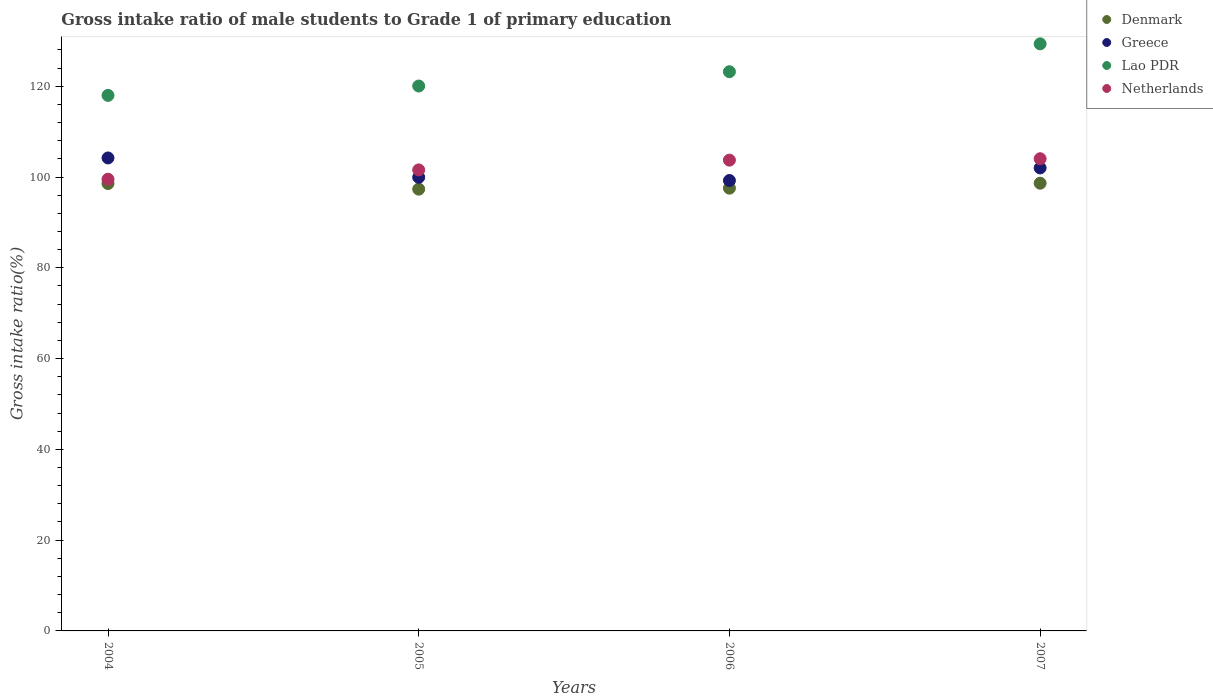Is the number of dotlines equal to the number of legend labels?
Your answer should be compact. Yes. What is the gross intake ratio in Lao PDR in 2004?
Give a very brief answer. 118. Across all years, what is the maximum gross intake ratio in Denmark?
Keep it short and to the point. 98.65. Across all years, what is the minimum gross intake ratio in Denmark?
Give a very brief answer. 97.34. What is the total gross intake ratio in Lao PDR in the graph?
Provide a short and direct response. 490.62. What is the difference between the gross intake ratio in Greece in 2004 and that in 2005?
Give a very brief answer. 4.26. What is the difference between the gross intake ratio in Denmark in 2006 and the gross intake ratio in Greece in 2007?
Ensure brevity in your answer.  -4.46. What is the average gross intake ratio in Greece per year?
Provide a succinct answer. 101.35. In the year 2005, what is the difference between the gross intake ratio in Lao PDR and gross intake ratio in Greece?
Make the answer very short. 20.11. What is the ratio of the gross intake ratio in Denmark in 2004 to that in 2007?
Provide a short and direct response. 1. Is the gross intake ratio in Denmark in 2005 less than that in 2006?
Keep it short and to the point. Yes. What is the difference between the highest and the second highest gross intake ratio in Netherlands?
Offer a very short reply. 0.31. What is the difference between the highest and the lowest gross intake ratio in Denmark?
Ensure brevity in your answer.  1.31. In how many years, is the gross intake ratio in Greece greater than the average gross intake ratio in Greece taken over all years?
Keep it short and to the point. 2. Is it the case that in every year, the sum of the gross intake ratio in Greece and gross intake ratio in Netherlands  is greater than the sum of gross intake ratio in Lao PDR and gross intake ratio in Denmark?
Provide a succinct answer. Yes. Is the gross intake ratio in Lao PDR strictly greater than the gross intake ratio in Denmark over the years?
Keep it short and to the point. Yes. How many years are there in the graph?
Offer a terse response. 4. What is the difference between two consecutive major ticks on the Y-axis?
Ensure brevity in your answer.  20. Does the graph contain any zero values?
Make the answer very short. No. Does the graph contain grids?
Your response must be concise. No. How many legend labels are there?
Your response must be concise. 4. How are the legend labels stacked?
Your answer should be very brief. Vertical. What is the title of the graph?
Provide a short and direct response. Gross intake ratio of male students to Grade 1 of primary education. Does "El Salvador" appear as one of the legend labels in the graph?
Ensure brevity in your answer.  No. What is the label or title of the X-axis?
Your answer should be very brief. Years. What is the label or title of the Y-axis?
Your answer should be very brief. Gross intake ratio(%). What is the Gross intake ratio(%) of Denmark in 2004?
Ensure brevity in your answer.  98.58. What is the Gross intake ratio(%) in Greece in 2004?
Offer a terse response. 104.21. What is the Gross intake ratio(%) of Lao PDR in 2004?
Offer a terse response. 118. What is the Gross intake ratio(%) of Netherlands in 2004?
Ensure brevity in your answer.  99.53. What is the Gross intake ratio(%) in Denmark in 2005?
Make the answer very short. 97.34. What is the Gross intake ratio(%) in Greece in 2005?
Your answer should be compact. 99.95. What is the Gross intake ratio(%) of Lao PDR in 2005?
Your response must be concise. 120.06. What is the Gross intake ratio(%) of Netherlands in 2005?
Offer a very short reply. 101.58. What is the Gross intake ratio(%) in Denmark in 2006?
Make the answer very short. 97.55. What is the Gross intake ratio(%) in Greece in 2006?
Give a very brief answer. 99.24. What is the Gross intake ratio(%) in Lao PDR in 2006?
Your answer should be very brief. 123.21. What is the Gross intake ratio(%) of Netherlands in 2006?
Make the answer very short. 103.73. What is the Gross intake ratio(%) in Denmark in 2007?
Ensure brevity in your answer.  98.65. What is the Gross intake ratio(%) in Greece in 2007?
Make the answer very short. 102.01. What is the Gross intake ratio(%) of Lao PDR in 2007?
Ensure brevity in your answer.  129.36. What is the Gross intake ratio(%) of Netherlands in 2007?
Your answer should be very brief. 104.04. Across all years, what is the maximum Gross intake ratio(%) of Denmark?
Provide a succinct answer. 98.65. Across all years, what is the maximum Gross intake ratio(%) in Greece?
Your answer should be compact. 104.21. Across all years, what is the maximum Gross intake ratio(%) of Lao PDR?
Provide a succinct answer. 129.36. Across all years, what is the maximum Gross intake ratio(%) of Netherlands?
Make the answer very short. 104.04. Across all years, what is the minimum Gross intake ratio(%) of Denmark?
Ensure brevity in your answer.  97.34. Across all years, what is the minimum Gross intake ratio(%) of Greece?
Your answer should be compact. 99.24. Across all years, what is the minimum Gross intake ratio(%) in Lao PDR?
Ensure brevity in your answer.  118. Across all years, what is the minimum Gross intake ratio(%) of Netherlands?
Give a very brief answer. 99.53. What is the total Gross intake ratio(%) in Denmark in the graph?
Offer a very short reply. 392.12. What is the total Gross intake ratio(%) in Greece in the graph?
Your response must be concise. 405.42. What is the total Gross intake ratio(%) in Lao PDR in the graph?
Your answer should be very brief. 490.62. What is the total Gross intake ratio(%) in Netherlands in the graph?
Your response must be concise. 408.88. What is the difference between the Gross intake ratio(%) of Denmark in 2004 and that in 2005?
Your answer should be very brief. 1.24. What is the difference between the Gross intake ratio(%) in Greece in 2004 and that in 2005?
Keep it short and to the point. 4.26. What is the difference between the Gross intake ratio(%) in Lao PDR in 2004 and that in 2005?
Your answer should be compact. -2.07. What is the difference between the Gross intake ratio(%) of Netherlands in 2004 and that in 2005?
Provide a succinct answer. -2.05. What is the difference between the Gross intake ratio(%) of Denmark in 2004 and that in 2006?
Offer a terse response. 1.03. What is the difference between the Gross intake ratio(%) in Greece in 2004 and that in 2006?
Offer a very short reply. 4.97. What is the difference between the Gross intake ratio(%) in Lao PDR in 2004 and that in 2006?
Make the answer very short. -5.22. What is the difference between the Gross intake ratio(%) in Netherlands in 2004 and that in 2006?
Your response must be concise. -4.2. What is the difference between the Gross intake ratio(%) of Denmark in 2004 and that in 2007?
Offer a very short reply. -0.07. What is the difference between the Gross intake ratio(%) of Greece in 2004 and that in 2007?
Your response must be concise. 2.2. What is the difference between the Gross intake ratio(%) of Lao PDR in 2004 and that in 2007?
Provide a short and direct response. -11.36. What is the difference between the Gross intake ratio(%) of Netherlands in 2004 and that in 2007?
Provide a succinct answer. -4.51. What is the difference between the Gross intake ratio(%) of Denmark in 2005 and that in 2006?
Keep it short and to the point. -0.21. What is the difference between the Gross intake ratio(%) of Greece in 2005 and that in 2006?
Provide a short and direct response. 0.71. What is the difference between the Gross intake ratio(%) of Lao PDR in 2005 and that in 2006?
Your response must be concise. -3.15. What is the difference between the Gross intake ratio(%) in Netherlands in 2005 and that in 2006?
Make the answer very short. -2.15. What is the difference between the Gross intake ratio(%) in Denmark in 2005 and that in 2007?
Offer a very short reply. -1.31. What is the difference between the Gross intake ratio(%) in Greece in 2005 and that in 2007?
Provide a short and direct response. -2.06. What is the difference between the Gross intake ratio(%) in Lao PDR in 2005 and that in 2007?
Ensure brevity in your answer.  -9.29. What is the difference between the Gross intake ratio(%) of Netherlands in 2005 and that in 2007?
Your answer should be compact. -2.46. What is the difference between the Gross intake ratio(%) in Denmark in 2006 and that in 2007?
Keep it short and to the point. -1.09. What is the difference between the Gross intake ratio(%) of Greece in 2006 and that in 2007?
Provide a succinct answer. -2.77. What is the difference between the Gross intake ratio(%) of Lao PDR in 2006 and that in 2007?
Ensure brevity in your answer.  -6.14. What is the difference between the Gross intake ratio(%) in Netherlands in 2006 and that in 2007?
Offer a very short reply. -0.31. What is the difference between the Gross intake ratio(%) of Denmark in 2004 and the Gross intake ratio(%) of Greece in 2005?
Give a very brief answer. -1.37. What is the difference between the Gross intake ratio(%) of Denmark in 2004 and the Gross intake ratio(%) of Lao PDR in 2005?
Offer a very short reply. -21.48. What is the difference between the Gross intake ratio(%) of Denmark in 2004 and the Gross intake ratio(%) of Netherlands in 2005?
Ensure brevity in your answer.  -3. What is the difference between the Gross intake ratio(%) of Greece in 2004 and the Gross intake ratio(%) of Lao PDR in 2005?
Provide a short and direct response. -15.85. What is the difference between the Gross intake ratio(%) in Greece in 2004 and the Gross intake ratio(%) in Netherlands in 2005?
Offer a very short reply. 2.63. What is the difference between the Gross intake ratio(%) in Lao PDR in 2004 and the Gross intake ratio(%) in Netherlands in 2005?
Offer a terse response. 16.41. What is the difference between the Gross intake ratio(%) of Denmark in 2004 and the Gross intake ratio(%) of Greece in 2006?
Give a very brief answer. -0.66. What is the difference between the Gross intake ratio(%) of Denmark in 2004 and the Gross intake ratio(%) of Lao PDR in 2006?
Ensure brevity in your answer.  -24.63. What is the difference between the Gross intake ratio(%) of Denmark in 2004 and the Gross intake ratio(%) of Netherlands in 2006?
Keep it short and to the point. -5.15. What is the difference between the Gross intake ratio(%) in Greece in 2004 and the Gross intake ratio(%) in Lao PDR in 2006?
Provide a short and direct response. -19. What is the difference between the Gross intake ratio(%) in Greece in 2004 and the Gross intake ratio(%) in Netherlands in 2006?
Offer a very short reply. 0.48. What is the difference between the Gross intake ratio(%) in Lao PDR in 2004 and the Gross intake ratio(%) in Netherlands in 2006?
Provide a succinct answer. 14.26. What is the difference between the Gross intake ratio(%) of Denmark in 2004 and the Gross intake ratio(%) of Greece in 2007?
Ensure brevity in your answer.  -3.43. What is the difference between the Gross intake ratio(%) in Denmark in 2004 and the Gross intake ratio(%) in Lao PDR in 2007?
Make the answer very short. -30.78. What is the difference between the Gross intake ratio(%) of Denmark in 2004 and the Gross intake ratio(%) of Netherlands in 2007?
Provide a succinct answer. -5.46. What is the difference between the Gross intake ratio(%) of Greece in 2004 and the Gross intake ratio(%) of Lao PDR in 2007?
Your response must be concise. -25.15. What is the difference between the Gross intake ratio(%) of Greece in 2004 and the Gross intake ratio(%) of Netherlands in 2007?
Your answer should be compact. 0.17. What is the difference between the Gross intake ratio(%) in Lao PDR in 2004 and the Gross intake ratio(%) in Netherlands in 2007?
Make the answer very short. 13.96. What is the difference between the Gross intake ratio(%) in Denmark in 2005 and the Gross intake ratio(%) in Greece in 2006?
Your answer should be compact. -1.9. What is the difference between the Gross intake ratio(%) in Denmark in 2005 and the Gross intake ratio(%) in Lao PDR in 2006?
Offer a terse response. -25.87. What is the difference between the Gross intake ratio(%) in Denmark in 2005 and the Gross intake ratio(%) in Netherlands in 2006?
Make the answer very short. -6.39. What is the difference between the Gross intake ratio(%) of Greece in 2005 and the Gross intake ratio(%) of Lao PDR in 2006?
Offer a terse response. -23.26. What is the difference between the Gross intake ratio(%) of Greece in 2005 and the Gross intake ratio(%) of Netherlands in 2006?
Provide a succinct answer. -3.78. What is the difference between the Gross intake ratio(%) in Lao PDR in 2005 and the Gross intake ratio(%) in Netherlands in 2006?
Your answer should be compact. 16.33. What is the difference between the Gross intake ratio(%) in Denmark in 2005 and the Gross intake ratio(%) in Greece in 2007?
Your response must be concise. -4.67. What is the difference between the Gross intake ratio(%) in Denmark in 2005 and the Gross intake ratio(%) in Lao PDR in 2007?
Make the answer very short. -32.02. What is the difference between the Gross intake ratio(%) of Denmark in 2005 and the Gross intake ratio(%) of Netherlands in 2007?
Provide a succinct answer. -6.7. What is the difference between the Gross intake ratio(%) of Greece in 2005 and the Gross intake ratio(%) of Lao PDR in 2007?
Make the answer very short. -29.4. What is the difference between the Gross intake ratio(%) in Greece in 2005 and the Gross intake ratio(%) in Netherlands in 2007?
Offer a terse response. -4.09. What is the difference between the Gross intake ratio(%) of Lao PDR in 2005 and the Gross intake ratio(%) of Netherlands in 2007?
Make the answer very short. 16.02. What is the difference between the Gross intake ratio(%) in Denmark in 2006 and the Gross intake ratio(%) in Greece in 2007?
Offer a terse response. -4.46. What is the difference between the Gross intake ratio(%) in Denmark in 2006 and the Gross intake ratio(%) in Lao PDR in 2007?
Your response must be concise. -31.8. What is the difference between the Gross intake ratio(%) in Denmark in 2006 and the Gross intake ratio(%) in Netherlands in 2007?
Offer a terse response. -6.49. What is the difference between the Gross intake ratio(%) in Greece in 2006 and the Gross intake ratio(%) in Lao PDR in 2007?
Offer a terse response. -30.11. What is the difference between the Gross intake ratio(%) in Greece in 2006 and the Gross intake ratio(%) in Netherlands in 2007?
Provide a succinct answer. -4.8. What is the difference between the Gross intake ratio(%) in Lao PDR in 2006 and the Gross intake ratio(%) in Netherlands in 2007?
Give a very brief answer. 19.17. What is the average Gross intake ratio(%) in Denmark per year?
Offer a very short reply. 98.03. What is the average Gross intake ratio(%) in Greece per year?
Your answer should be very brief. 101.35. What is the average Gross intake ratio(%) of Lao PDR per year?
Provide a succinct answer. 122.66. What is the average Gross intake ratio(%) in Netherlands per year?
Keep it short and to the point. 102.22. In the year 2004, what is the difference between the Gross intake ratio(%) in Denmark and Gross intake ratio(%) in Greece?
Make the answer very short. -5.63. In the year 2004, what is the difference between the Gross intake ratio(%) in Denmark and Gross intake ratio(%) in Lao PDR?
Keep it short and to the point. -19.42. In the year 2004, what is the difference between the Gross intake ratio(%) of Denmark and Gross intake ratio(%) of Netherlands?
Provide a short and direct response. -0.95. In the year 2004, what is the difference between the Gross intake ratio(%) of Greece and Gross intake ratio(%) of Lao PDR?
Make the answer very short. -13.79. In the year 2004, what is the difference between the Gross intake ratio(%) in Greece and Gross intake ratio(%) in Netherlands?
Give a very brief answer. 4.68. In the year 2004, what is the difference between the Gross intake ratio(%) of Lao PDR and Gross intake ratio(%) of Netherlands?
Make the answer very short. 18.47. In the year 2005, what is the difference between the Gross intake ratio(%) in Denmark and Gross intake ratio(%) in Greece?
Provide a short and direct response. -2.61. In the year 2005, what is the difference between the Gross intake ratio(%) of Denmark and Gross intake ratio(%) of Lao PDR?
Your answer should be very brief. -22.72. In the year 2005, what is the difference between the Gross intake ratio(%) of Denmark and Gross intake ratio(%) of Netherlands?
Provide a short and direct response. -4.24. In the year 2005, what is the difference between the Gross intake ratio(%) of Greece and Gross intake ratio(%) of Lao PDR?
Your answer should be very brief. -20.11. In the year 2005, what is the difference between the Gross intake ratio(%) of Greece and Gross intake ratio(%) of Netherlands?
Keep it short and to the point. -1.63. In the year 2005, what is the difference between the Gross intake ratio(%) in Lao PDR and Gross intake ratio(%) in Netherlands?
Your answer should be very brief. 18.48. In the year 2006, what is the difference between the Gross intake ratio(%) of Denmark and Gross intake ratio(%) of Greece?
Ensure brevity in your answer.  -1.69. In the year 2006, what is the difference between the Gross intake ratio(%) of Denmark and Gross intake ratio(%) of Lao PDR?
Provide a short and direct response. -25.66. In the year 2006, what is the difference between the Gross intake ratio(%) of Denmark and Gross intake ratio(%) of Netherlands?
Provide a succinct answer. -6.18. In the year 2006, what is the difference between the Gross intake ratio(%) of Greece and Gross intake ratio(%) of Lao PDR?
Make the answer very short. -23.97. In the year 2006, what is the difference between the Gross intake ratio(%) in Greece and Gross intake ratio(%) in Netherlands?
Your response must be concise. -4.49. In the year 2006, what is the difference between the Gross intake ratio(%) in Lao PDR and Gross intake ratio(%) in Netherlands?
Make the answer very short. 19.48. In the year 2007, what is the difference between the Gross intake ratio(%) of Denmark and Gross intake ratio(%) of Greece?
Make the answer very short. -3.37. In the year 2007, what is the difference between the Gross intake ratio(%) in Denmark and Gross intake ratio(%) in Lao PDR?
Your response must be concise. -30.71. In the year 2007, what is the difference between the Gross intake ratio(%) in Denmark and Gross intake ratio(%) in Netherlands?
Offer a very short reply. -5.39. In the year 2007, what is the difference between the Gross intake ratio(%) in Greece and Gross intake ratio(%) in Lao PDR?
Make the answer very short. -27.34. In the year 2007, what is the difference between the Gross intake ratio(%) of Greece and Gross intake ratio(%) of Netherlands?
Make the answer very short. -2.03. In the year 2007, what is the difference between the Gross intake ratio(%) of Lao PDR and Gross intake ratio(%) of Netherlands?
Your answer should be compact. 25.32. What is the ratio of the Gross intake ratio(%) of Denmark in 2004 to that in 2005?
Provide a succinct answer. 1.01. What is the ratio of the Gross intake ratio(%) in Greece in 2004 to that in 2005?
Make the answer very short. 1.04. What is the ratio of the Gross intake ratio(%) of Lao PDR in 2004 to that in 2005?
Give a very brief answer. 0.98. What is the ratio of the Gross intake ratio(%) in Netherlands in 2004 to that in 2005?
Your response must be concise. 0.98. What is the ratio of the Gross intake ratio(%) of Denmark in 2004 to that in 2006?
Keep it short and to the point. 1.01. What is the ratio of the Gross intake ratio(%) in Greece in 2004 to that in 2006?
Keep it short and to the point. 1.05. What is the ratio of the Gross intake ratio(%) in Lao PDR in 2004 to that in 2006?
Ensure brevity in your answer.  0.96. What is the ratio of the Gross intake ratio(%) of Netherlands in 2004 to that in 2006?
Provide a succinct answer. 0.96. What is the ratio of the Gross intake ratio(%) in Greece in 2004 to that in 2007?
Keep it short and to the point. 1.02. What is the ratio of the Gross intake ratio(%) of Lao PDR in 2004 to that in 2007?
Keep it short and to the point. 0.91. What is the ratio of the Gross intake ratio(%) in Netherlands in 2004 to that in 2007?
Provide a succinct answer. 0.96. What is the ratio of the Gross intake ratio(%) of Denmark in 2005 to that in 2006?
Make the answer very short. 1. What is the ratio of the Gross intake ratio(%) in Lao PDR in 2005 to that in 2006?
Offer a terse response. 0.97. What is the ratio of the Gross intake ratio(%) in Netherlands in 2005 to that in 2006?
Offer a very short reply. 0.98. What is the ratio of the Gross intake ratio(%) in Denmark in 2005 to that in 2007?
Make the answer very short. 0.99. What is the ratio of the Gross intake ratio(%) in Greece in 2005 to that in 2007?
Make the answer very short. 0.98. What is the ratio of the Gross intake ratio(%) in Lao PDR in 2005 to that in 2007?
Your answer should be compact. 0.93. What is the ratio of the Gross intake ratio(%) of Netherlands in 2005 to that in 2007?
Offer a terse response. 0.98. What is the ratio of the Gross intake ratio(%) in Denmark in 2006 to that in 2007?
Give a very brief answer. 0.99. What is the ratio of the Gross intake ratio(%) in Greece in 2006 to that in 2007?
Ensure brevity in your answer.  0.97. What is the ratio of the Gross intake ratio(%) in Lao PDR in 2006 to that in 2007?
Give a very brief answer. 0.95. What is the difference between the highest and the second highest Gross intake ratio(%) of Denmark?
Your answer should be very brief. 0.07. What is the difference between the highest and the second highest Gross intake ratio(%) in Greece?
Make the answer very short. 2.2. What is the difference between the highest and the second highest Gross intake ratio(%) in Lao PDR?
Your response must be concise. 6.14. What is the difference between the highest and the second highest Gross intake ratio(%) in Netherlands?
Offer a terse response. 0.31. What is the difference between the highest and the lowest Gross intake ratio(%) of Denmark?
Your answer should be very brief. 1.31. What is the difference between the highest and the lowest Gross intake ratio(%) in Greece?
Your answer should be compact. 4.97. What is the difference between the highest and the lowest Gross intake ratio(%) in Lao PDR?
Keep it short and to the point. 11.36. What is the difference between the highest and the lowest Gross intake ratio(%) in Netherlands?
Keep it short and to the point. 4.51. 